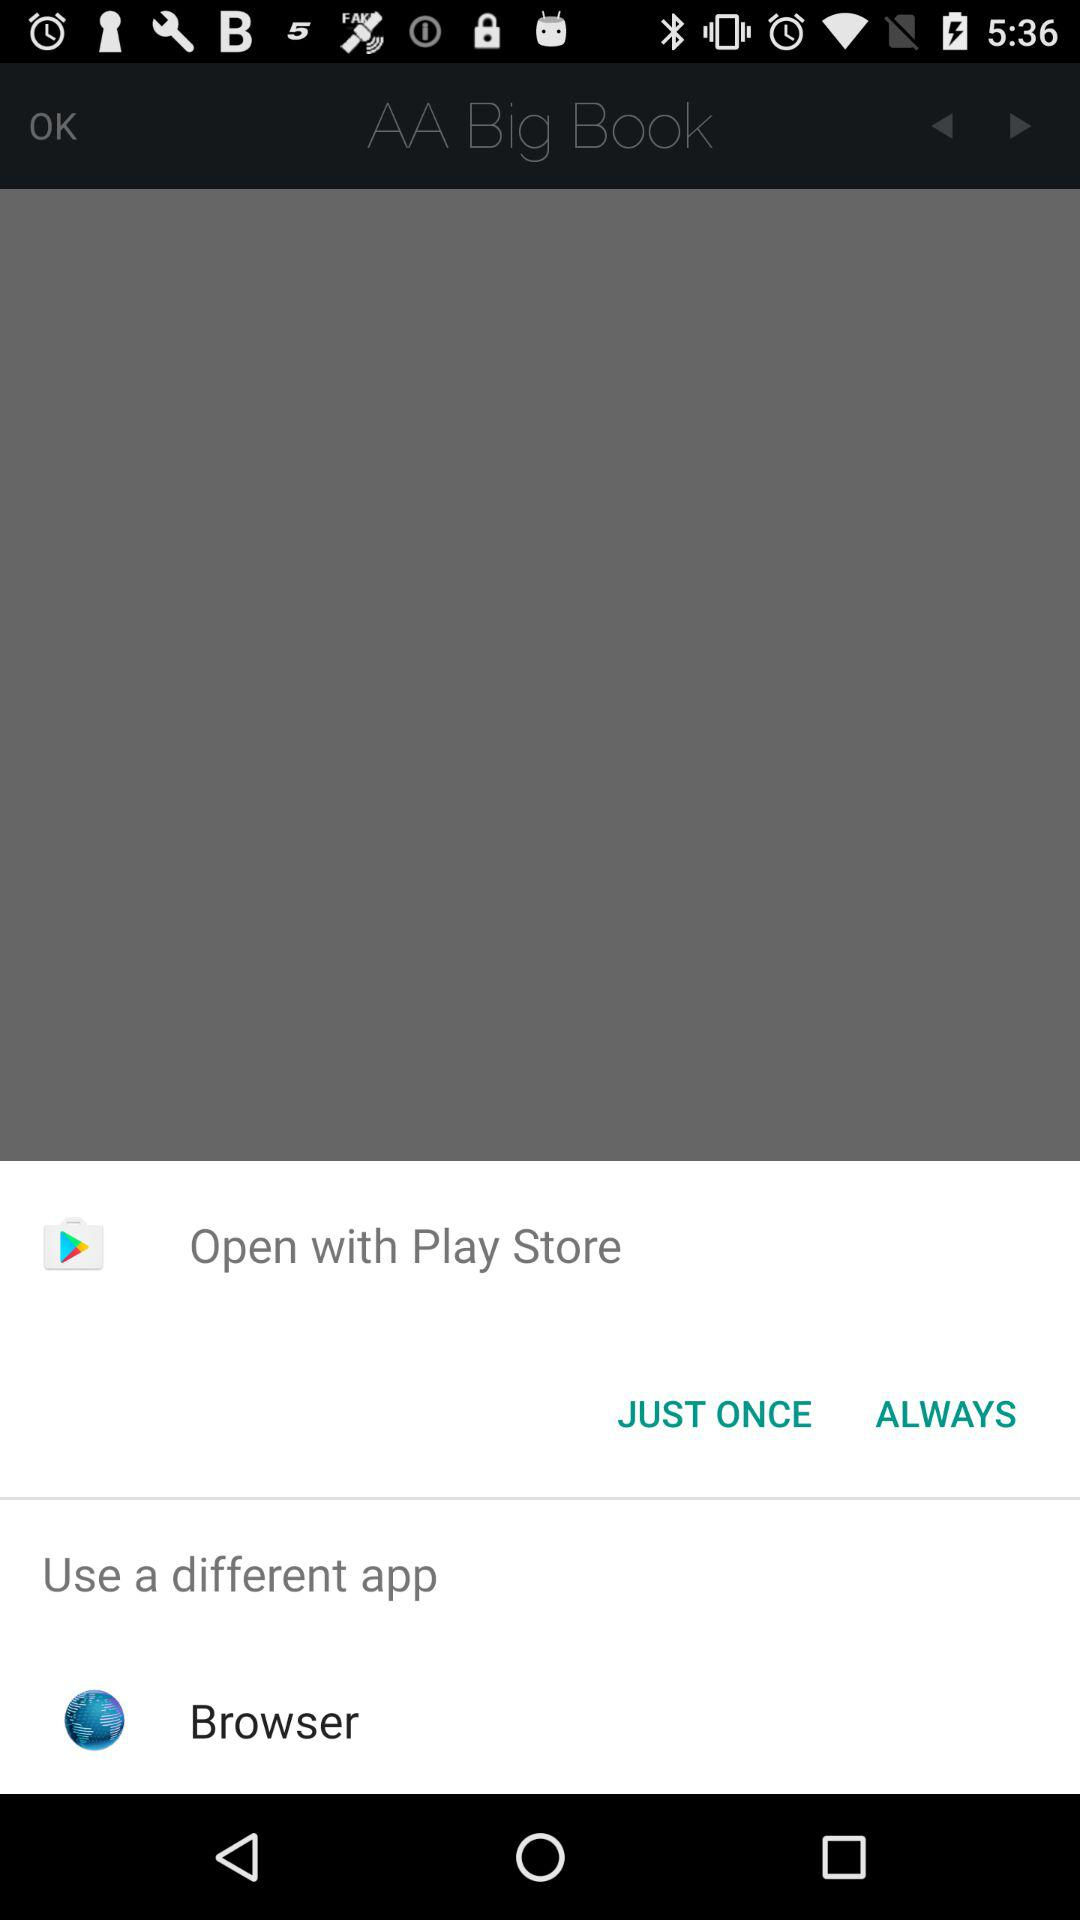What different app can I use to open it? You can use "Browser" to open it. 